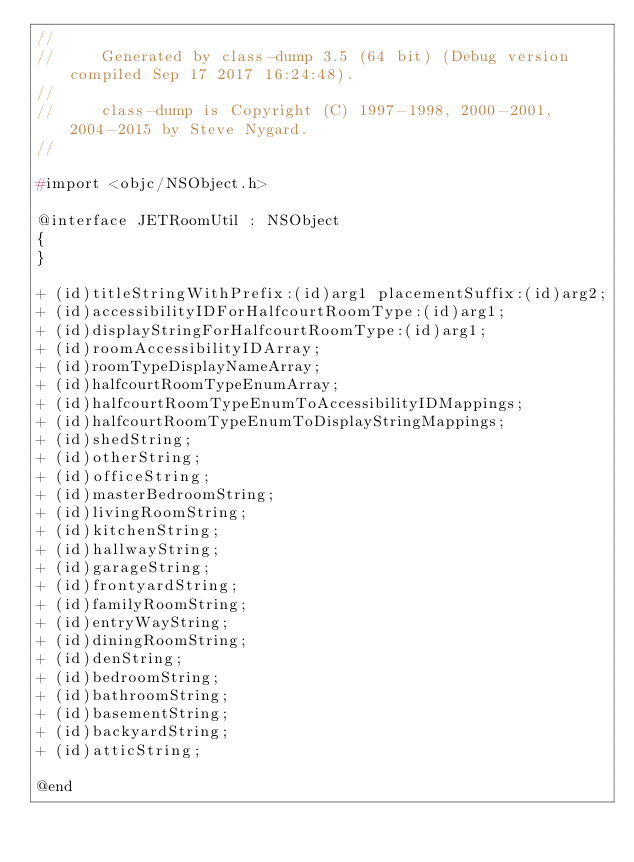<code> <loc_0><loc_0><loc_500><loc_500><_C_>//
//     Generated by class-dump 3.5 (64 bit) (Debug version compiled Sep 17 2017 16:24:48).
//
//     class-dump is Copyright (C) 1997-1998, 2000-2001, 2004-2015 by Steve Nygard.
//

#import <objc/NSObject.h>

@interface JETRoomUtil : NSObject
{
}

+ (id)titleStringWithPrefix:(id)arg1 placementSuffix:(id)arg2;
+ (id)accessibilityIDForHalfcourtRoomType:(id)arg1;
+ (id)displayStringForHalfcourtRoomType:(id)arg1;
+ (id)roomAccessibilityIDArray;
+ (id)roomTypeDisplayNameArray;
+ (id)halfcourtRoomTypeEnumArray;
+ (id)halfcourtRoomTypeEnumToAccessibilityIDMappings;
+ (id)halfcourtRoomTypeEnumToDisplayStringMappings;
+ (id)shedString;
+ (id)otherString;
+ (id)officeString;
+ (id)masterBedroomString;
+ (id)livingRoomString;
+ (id)kitchenString;
+ (id)hallwayString;
+ (id)garageString;
+ (id)frontyardString;
+ (id)familyRoomString;
+ (id)entryWayString;
+ (id)diningRoomString;
+ (id)denString;
+ (id)bedroomString;
+ (id)bathroomString;
+ (id)basementString;
+ (id)backyardString;
+ (id)atticString;

@end

</code> 